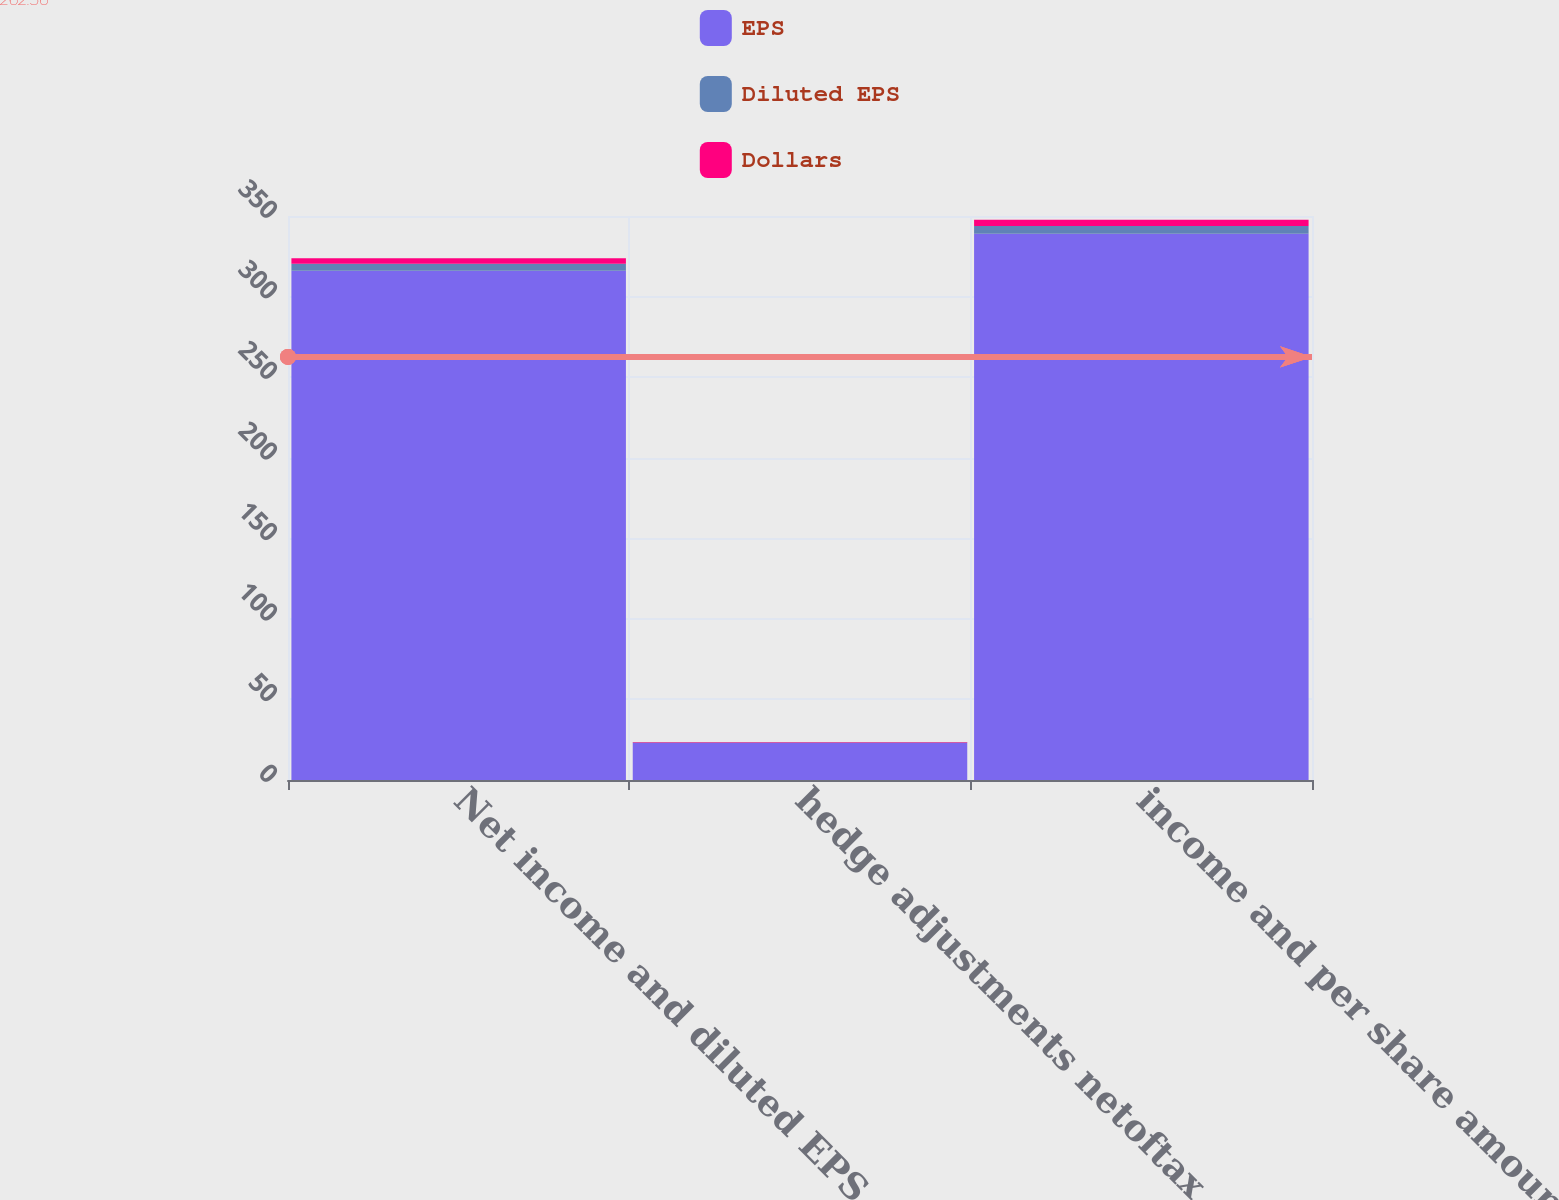<chart> <loc_0><loc_0><loc_500><loc_500><stacked_bar_chart><ecel><fcel>Net income and diluted EPS as<fcel>hedge adjustments netoftax<fcel>income and per share amounts<nl><fcel>EPS<fcel>316<fcel>23<fcel>339<nl><fcel>Diluted EPS<fcel>4.4<fcel>0.33<fcel>4.73<nl><fcel>Dollars<fcel>3.33<fcel>0.26<fcel>3.92<nl></chart> 